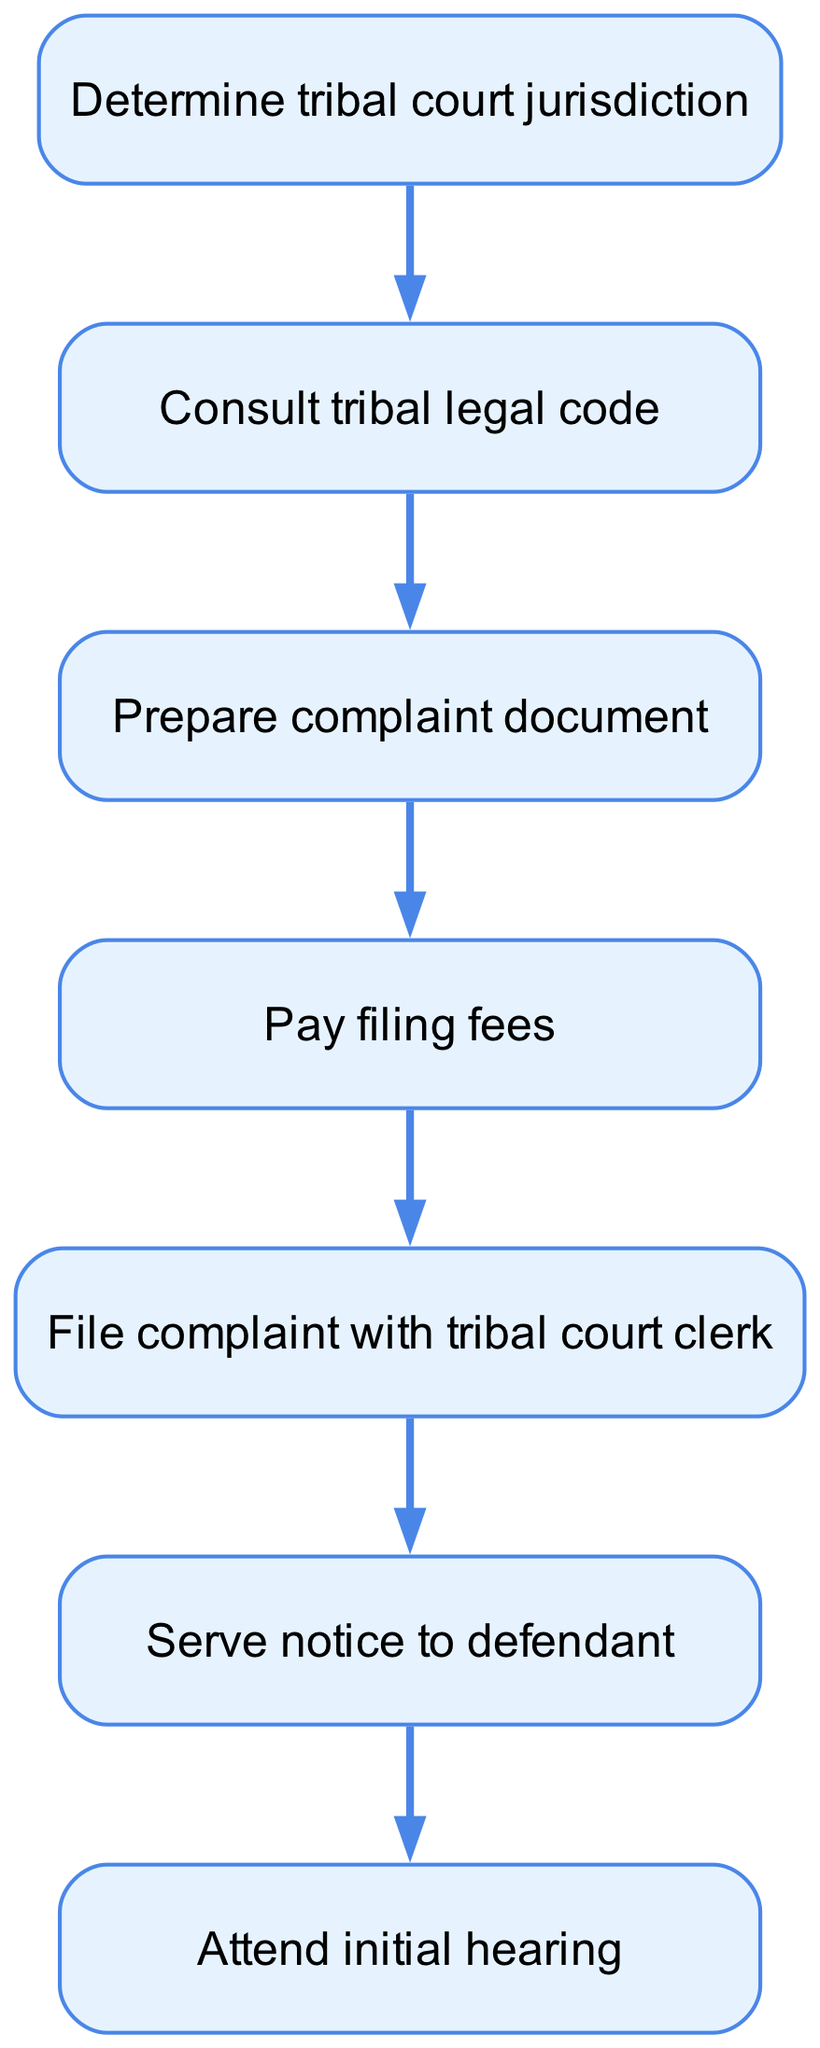What is the first step in filing a lawsuit in tribal court? The first step in the flow chart is "Determine tribal court jurisdiction," which is indicated as the first node in the diagram.
Answer: Determine tribal court jurisdiction What follows after "Consult tribal legal code"? After "Consult tribal legal code," the next step indicated in the diagram is "Prepare complaint document," which is the next node connected to it.
Answer: Prepare complaint document How many steps are there in total? By counting the nodes in the diagram, there are a total of seven steps outlined for filing a lawsuit in the tribal court.
Answer: Seven What is the last action taken according to the flow chart? The last action outlined in the flow chart is "Attend initial hearing," which is presented as the final node with no subsequent steps.
Answer: Attend initial hearing Which step requires payment? The step that requires payment as indicated in the diagram is "Pay filing fees," which is an explicit action in the process.
Answer: Pay filing fees What is the sequence of steps from preparing the complaint document to attending the initial hearing? After "Prepare complaint document," the sequence continues with "Pay filing fees," then "File complaint with tribal court clerk," followed by "Serve notice to defendant," and concludes with "Attend initial hearing."
Answer: Pay filing fees, File complaint with tribal court clerk, Serve notice to defendant, Attend initial hearing Which step has a direct connection to serving notice to the defendant? The step that has a direct connection to serving notice to the defendant, as represented in the diagram, is "File complaint with tribal court clerk," which precedes it in the flow.
Answer: File complaint with tribal court clerk What is the connection between "Determine tribal court jurisdiction" and "Attend initial hearing"? "Determine tribal court jurisdiction" is the starting point; it leads to each subsequent step until the last step "Attend initial hearing," illustrating the complete process from start to finish.
Answer: Sequential steps leading to the last step 